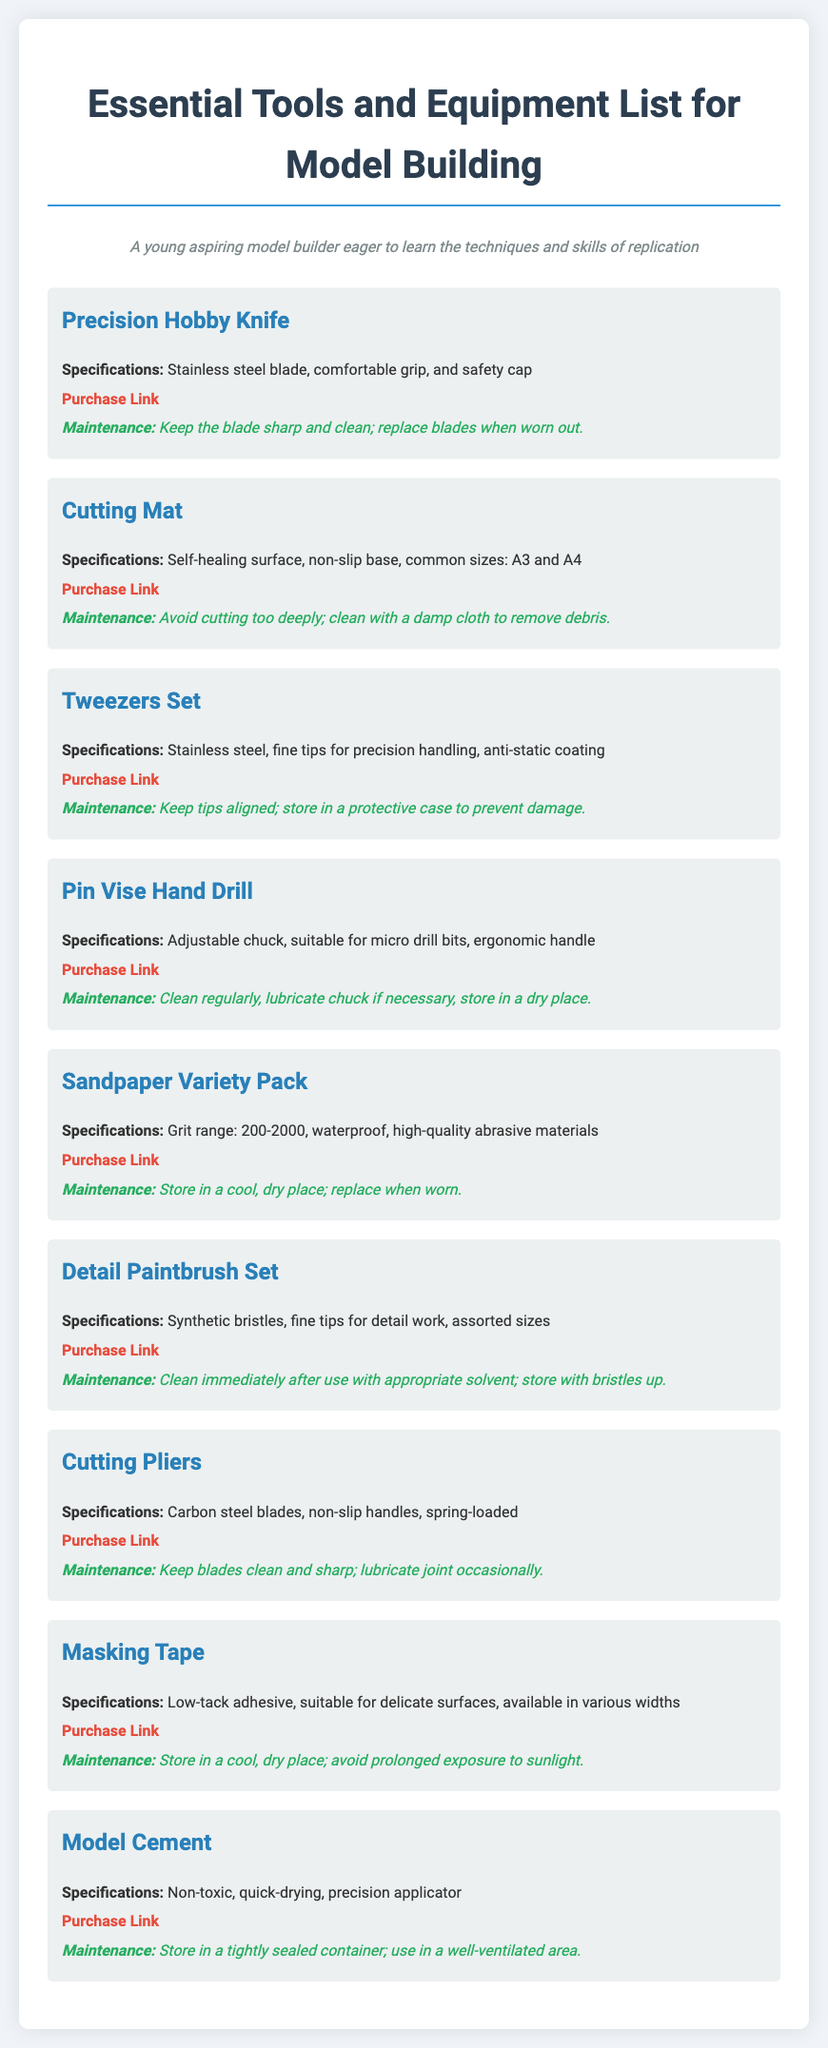What is the first item listed? The first item listed in the document is the "Precision Hobby Knife."
Answer: Precision Hobby Knife What material are the tweezers made of? The tweezers in the document are made of stainless steel.
Answer: Stainless steel How many common sizes are mentioned for the Cutting Mat? The document mentions two common sizes for the Cutting Mat: A3 and A4.
Answer: Two What is the grit range of the Sandpaper Variety Pack? The grit range of the Sandpaper Variety Pack is from 200 to 2000.
Answer: 200-2000 What should be done with the Detail Paintbrush Set after use? After use, the Detail Paintbrush Set should be cleaned immediately with an appropriate solvent.
Answer: Clean immediately What is the purchase link for the Model Cement? The purchase link for the Model Cement is found at "https://www.modelkitsupplies.com/model-cement."
Answer: https://www.modelkitsupplies.com/model-cement What type of adhesive is the Masking Tape described as? The Masking Tape is described as having a low-tack adhesive.
Answer: Low-tack adhesive Which tool requires lubrication of the chuck? The tool requiring lubrication of the chuck is the Pin Vise Hand Drill.
Answer: Pin Vise Hand Drill 